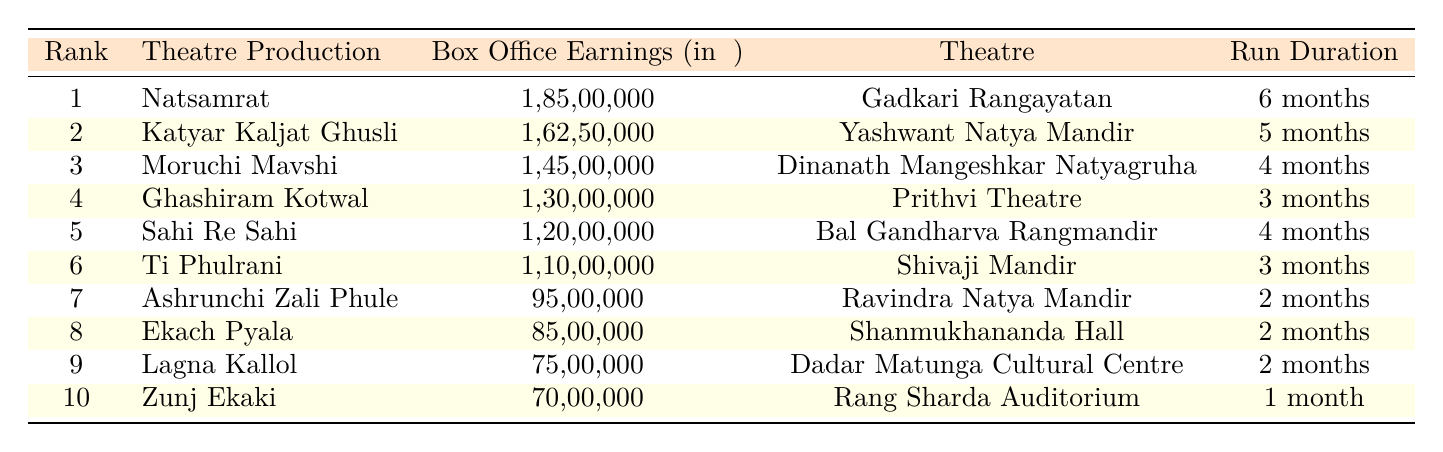What's the box office earning of "Natsamrat"? The table lists "Natsamrat" in rank 1 and shows its box office earnings as 1,85,00,000.
Answer: 1,85,00,000 Which theatre production has the lowest box office earnings? From the table, the production with the lowest earnings is "Zunj Ekaki," listed at rank 10 with 70,00,000.
Answer: Zunj Ekaki What is the total box office earnings of the top 3 productions? The top 3 productions are "Natsamrat," "Katyar Kaljat Ghusli," and "Moruchi Mavshi." Their earnings are 1,85,00,000 + 1,62,50,000 + 1,45,00,000 = 4,92,50,000.
Answer: 4,92,50,000 Does "Ekach Pyala" have higher earnings than "Ashrunchi Zali Phule"? Comparing the earnings from the table, "Ekach Pyala" has earnings of 85,00,000 while "Ashrunchi Zali Phule" has 95,00,000. Since 85,00,000 is less than 95,00,000, the answer is no.
Answer: No What is the average run duration of all listed productions? The run durations are 6 months, 5 months, 4 months, 3 months, 4 months, 3 months, 2 months, 2 months, 2 months, and 1 month. Converting these to a total number of months: 6+5+4+3+4+3+2+2+2+1 = 32 months. There are 10 productions, so the average is 32/10 = 3.2 months.
Answer: 3.2 months Which theatre production had box office earnings greater than 1 crore but less than 1.5 crore? From the table, "Moruchi Mavshi" has earnings of 1,45,00,000, which is greater than 1 crore and less than 1.5 crore. No other production fits this range in the provided data.
Answer: Moruchi Mavshi How many months did "Ghashiram Kotwal" run? The table states that "Ghashiram Kotwal" ran for 3 months.
Answer: 3 months Is there a production that earned more than 1.5 crore? By checking the box office earnings in the table, all listed productions have earnings below 1.5 crore, so the answer is no.
Answer: No 